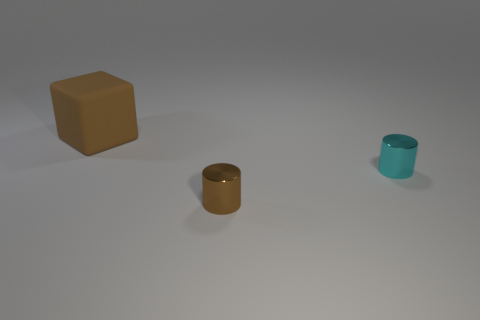Is the shape of the large brown object the same as the brown shiny thing?
Your answer should be very brief. No. There is a metallic thing to the right of the brown thing that is in front of the large brown matte thing; what number of big brown matte cubes are in front of it?
Your answer should be compact. 0. There is a thing that is to the left of the cyan metallic thing and behind the small brown cylinder; what material is it made of?
Provide a short and direct response. Rubber. There is a object that is both left of the small cyan metallic cylinder and on the right side of the large brown block; what color is it?
Provide a succinct answer. Brown. Is there any other thing that has the same color as the matte object?
Offer a terse response. Yes. What shape is the brown object that is behind the small metallic cylinder that is in front of the small cylinder behind the brown metal thing?
Keep it short and to the point. Cube. There is another tiny thing that is the same shape as the brown metallic thing; what is its color?
Provide a succinct answer. Cyan. What color is the tiny cylinder behind the brown thing that is in front of the tiny cyan object?
Your response must be concise. Cyan. There is another metal thing that is the same shape as the cyan shiny object; what size is it?
Make the answer very short. Small. How many large brown things have the same material as the cube?
Your response must be concise. 0. 